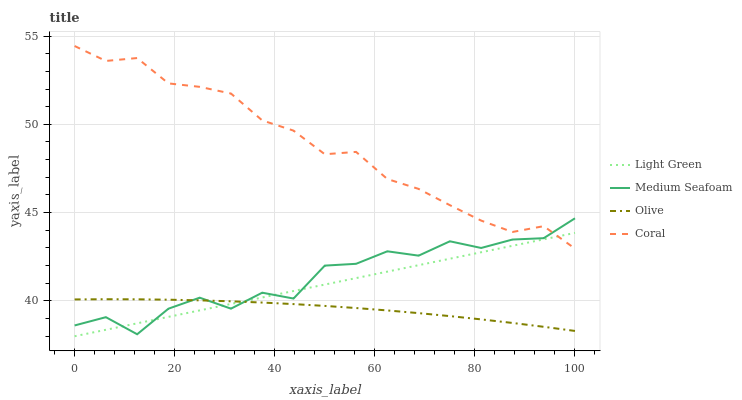Does Olive have the minimum area under the curve?
Answer yes or no. Yes. Does Coral have the maximum area under the curve?
Answer yes or no. Yes. Does Medium Seafoam have the minimum area under the curve?
Answer yes or no. No. Does Medium Seafoam have the maximum area under the curve?
Answer yes or no. No. Is Light Green the smoothest?
Answer yes or no. Yes. Is Medium Seafoam the roughest?
Answer yes or no. Yes. Is Coral the smoothest?
Answer yes or no. No. Is Coral the roughest?
Answer yes or no. No. Does Light Green have the lowest value?
Answer yes or no. Yes. Does Medium Seafoam have the lowest value?
Answer yes or no. No. Does Coral have the highest value?
Answer yes or no. Yes. Does Medium Seafoam have the highest value?
Answer yes or no. No. Is Olive less than Coral?
Answer yes or no. Yes. Is Coral greater than Olive?
Answer yes or no. Yes. Does Olive intersect Medium Seafoam?
Answer yes or no. Yes. Is Olive less than Medium Seafoam?
Answer yes or no. No. Is Olive greater than Medium Seafoam?
Answer yes or no. No. Does Olive intersect Coral?
Answer yes or no. No. 